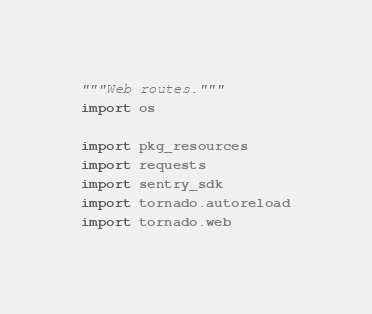<code> <loc_0><loc_0><loc_500><loc_500><_Python_>"""Web routes."""
import os

import pkg_resources
import requests
import sentry_sdk
import tornado.autoreload
import tornado.web</code> 